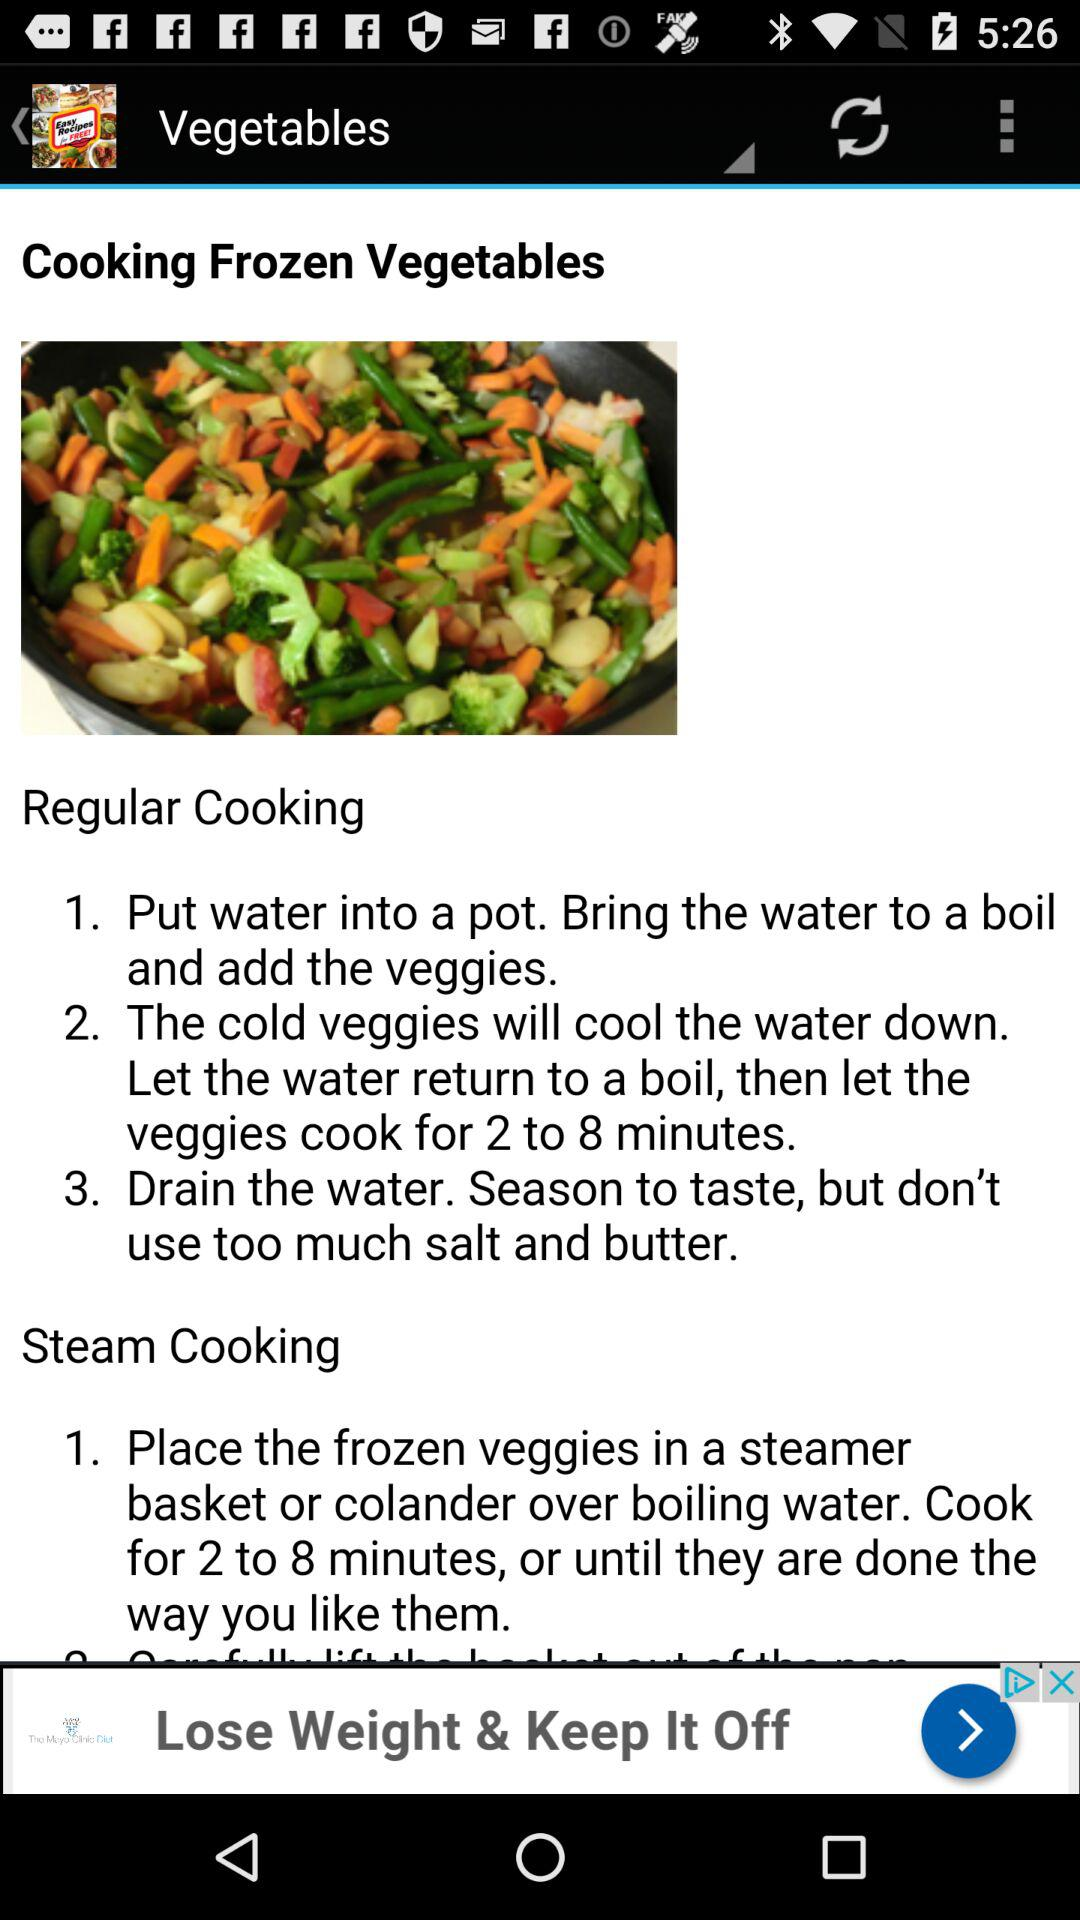What are the steps to follow for regular cooking of frozen vegetables? The steps to follow for regular cooking of frozen vegetables are "1. Put water into a pot. Bring the water to a boil and add the veggies.", "2. The cold veggies will cool the water down. Let the water return to a boil, then let the veggies cook for 2 to 8 minutes." and "3. Drain the water. Season to taste, but don't use too much salt and butter.". 